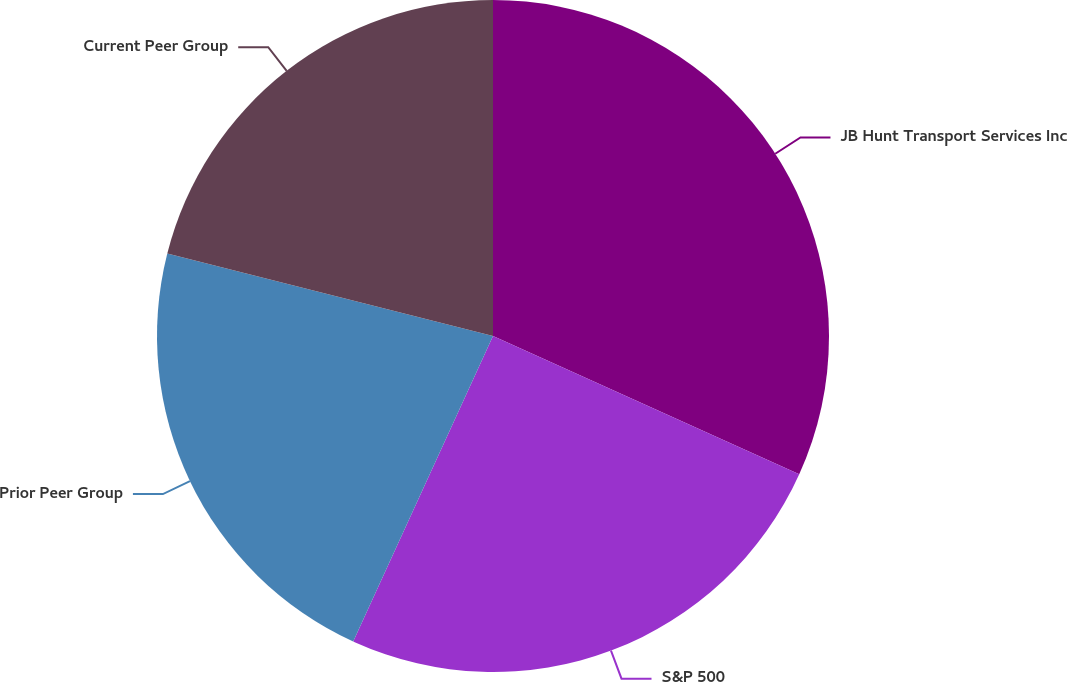Convert chart to OTSL. <chart><loc_0><loc_0><loc_500><loc_500><pie_chart><fcel>JB Hunt Transport Services Inc<fcel>S&P 500<fcel>Prior Peer Group<fcel>Current Peer Group<nl><fcel>31.75%<fcel>25.08%<fcel>22.12%<fcel>21.05%<nl></chart> 